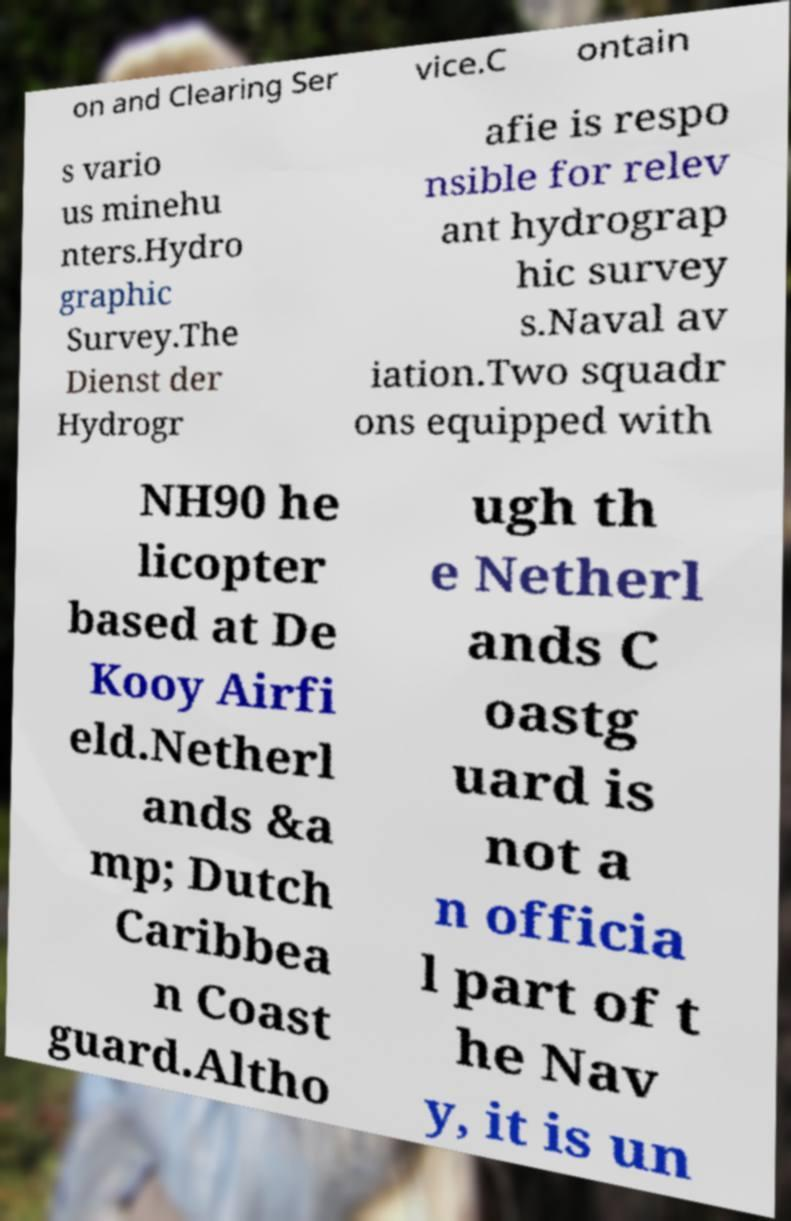Please identify and transcribe the text found in this image. on and Clearing Ser vice.C ontain s vario us minehu nters.Hydro graphic Survey.The Dienst der Hydrogr afie is respo nsible for relev ant hydrograp hic survey s.Naval av iation.Two squadr ons equipped with NH90 he licopter based at De Kooy Airfi eld.Netherl ands &a mp; Dutch Caribbea n Coast guard.Altho ugh th e Netherl ands C oastg uard is not a n officia l part of t he Nav y, it is un 